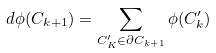Convert formula to latex. <formula><loc_0><loc_0><loc_500><loc_500>d \phi ( C _ { k + 1 } ) = \sum _ { C ^ { \prime } _ { K } \in \partial C _ { k + 1 } } \phi ( C ^ { \prime } _ { k } )</formula> 